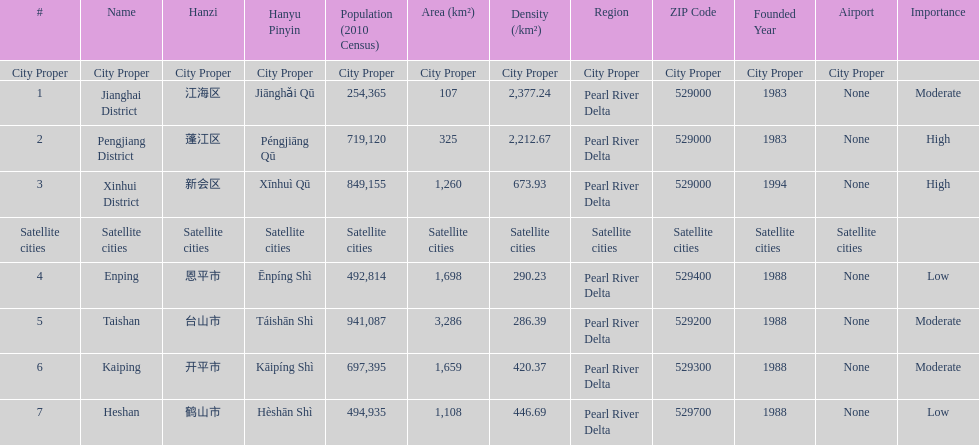What is the most populated district? Taishan. Write the full table. {'header': ['#', 'Name', 'Hanzi', 'Hanyu Pinyin', 'Population (2010 Census)', 'Area (km²)', 'Density (/km²)', 'Region', 'ZIP Code', 'Founded Year', 'Airport', 'Importance'], 'rows': [['City Proper', 'City Proper', 'City Proper', 'City Proper', 'City Proper', 'City Proper', 'City Proper', 'City Proper', 'City Proper', 'City Proper', 'City Proper', ''], ['1', 'Jianghai District', '江海区', 'Jiānghǎi Qū', '254,365', '107', '2,377.24', 'Pearl River Delta', '529000', '1983', 'None', 'Moderate'], ['2', 'Pengjiang District', '蓬江区', 'Péngjiāng Qū', '719,120', '325', '2,212.67', 'Pearl River Delta', '529000', '1983', 'None', 'High'], ['3', 'Xinhui District', '新会区', 'Xīnhuì Qū', '849,155', '1,260', '673.93', 'Pearl River Delta', '529000', '1994', 'None', 'High'], ['Satellite cities', 'Satellite cities', 'Satellite cities', 'Satellite cities', 'Satellite cities', 'Satellite cities', 'Satellite cities', 'Satellite cities', 'Satellite cities', 'Satellite cities', 'Satellite cities', ''], ['4', 'Enping', '恩平市', 'Ēnpíng Shì', '492,814', '1,698', '290.23', 'Pearl River Delta', '529400', '1988', 'None', 'Low'], ['5', 'Taishan', '台山市', 'Táishān Shì', '941,087', '3,286', '286.39', 'Pearl River Delta', '529200', '1988', 'None', 'Moderate'], ['6', 'Kaiping', '开平市', 'Kāipíng Shì', '697,395', '1,659', '420.37', 'Pearl River Delta', '529300', '1988', 'None', 'Moderate'], ['7', 'Heshan', '鹤山市', 'Hèshān Shì', '494,935', '1,108', '446.69', 'Pearl River Delta', '529700', '1988', 'None', 'Low']]} 